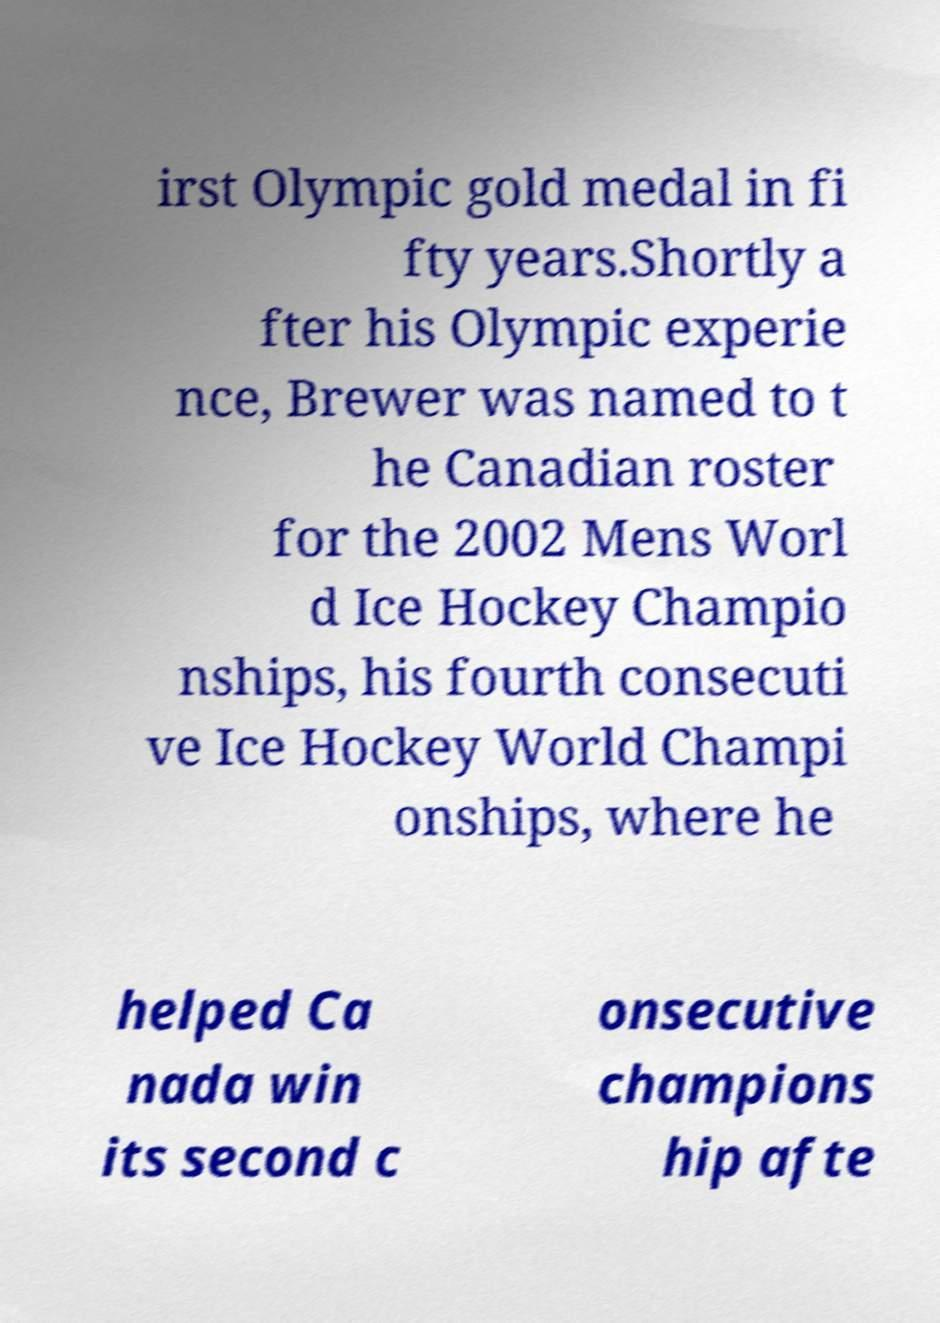Can you read and provide the text displayed in the image?This photo seems to have some interesting text. Can you extract and type it out for me? irst Olympic gold medal in fi fty years.Shortly a fter his Olympic experie nce, Brewer was named to t he Canadian roster for the 2002 Mens Worl d Ice Hockey Champio nships, his fourth consecuti ve Ice Hockey World Champi onships, where he helped Ca nada win its second c onsecutive champions hip afte 